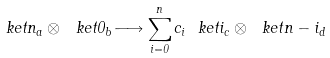Convert formula to latex. <formula><loc_0><loc_0><loc_500><loc_500>\ k e t { n } _ { a } \otimes \ k e t { 0 } _ { b } \longrightarrow \sum _ { i = 0 } ^ { n } c _ { i } \ k e t { i } _ { c } \otimes \ k e t { n - i } _ { d }</formula> 